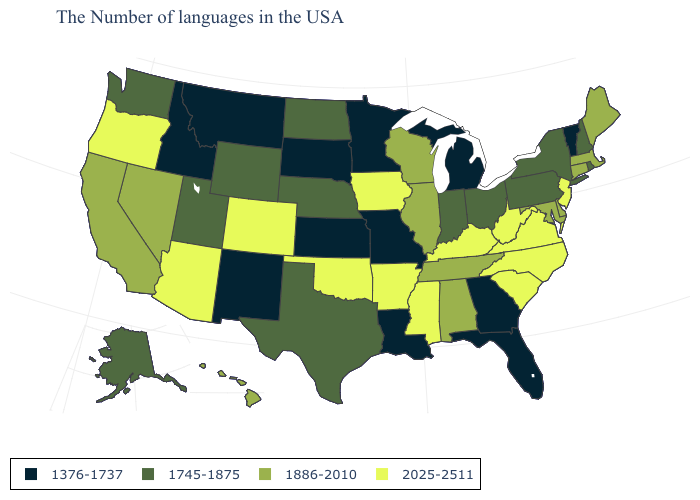What is the value of South Dakota?
Quick response, please. 1376-1737. How many symbols are there in the legend?
Give a very brief answer. 4. What is the highest value in states that border California?
Concise answer only. 2025-2511. What is the value of Washington?
Quick response, please. 1745-1875. Name the states that have a value in the range 1886-2010?
Concise answer only. Maine, Massachusetts, Connecticut, Delaware, Maryland, Alabama, Tennessee, Wisconsin, Illinois, Nevada, California, Hawaii. Does Louisiana have the lowest value in the USA?
Short answer required. Yes. What is the value of Arkansas?
Give a very brief answer. 2025-2511. Which states hav the highest value in the West?
Keep it brief. Colorado, Arizona, Oregon. Which states have the lowest value in the South?
Write a very short answer. Florida, Georgia, Louisiana. Does West Virginia have the highest value in the USA?
Short answer required. Yes. Among the states that border Arkansas , which have the lowest value?
Be succinct. Louisiana, Missouri. What is the value of Massachusetts?
Keep it brief. 1886-2010. Among the states that border Washington , which have the lowest value?
Be succinct. Idaho. What is the highest value in states that border Massachusetts?
Concise answer only. 1886-2010. What is the value of Virginia?
Keep it brief. 2025-2511. 